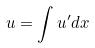<formula> <loc_0><loc_0><loc_500><loc_500>u = \int u ^ { \prime } d x</formula> 